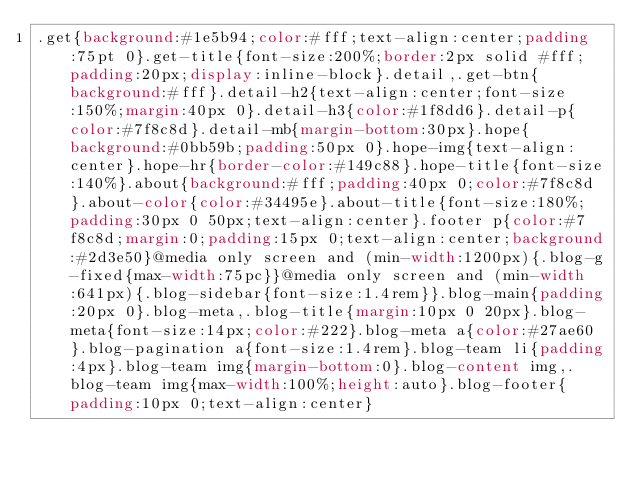<code> <loc_0><loc_0><loc_500><loc_500><_CSS_>.get{background:#1e5b94;color:#fff;text-align:center;padding:75pt 0}.get-title{font-size:200%;border:2px solid #fff;padding:20px;display:inline-block}.detail,.get-btn{background:#fff}.detail-h2{text-align:center;font-size:150%;margin:40px 0}.detail-h3{color:#1f8dd6}.detail-p{color:#7f8c8d}.detail-mb{margin-bottom:30px}.hope{background:#0bb59b;padding:50px 0}.hope-img{text-align:center}.hope-hr{border-color:#149c88}.hope-title{font-size:140%}.about{background:#fff;padding:40px 0;color:#7f8c8d}.about-color{color:#34495e}.about-title{font-size:180%;padding:30px 0 50px;text-align:center}.footer p{color:#7f8c8d;margin:0;padding:15px 0;text-align:center;background:#2d3e50}@media only screen and (min-width:1200px){.blog-g-fixed{max-width:75pc}}@media only screen and (min-width:641px){.blog-sidebar{font-size:1.4rem}}.blog-main{padding:20px 0}.blog-meta,.blog-title{margin:10px 0 20px}.blog-meta{font-size:14px;color:#222}.blog-meta a{color:#27ae60}.blog-pagination a{font-size:1.4rem}.blog-team li{padding:4px}.blog-team img{margin-bottom:0}.blog-content img,.blog-team img{max-width:100%;height:auto}.blog-footer{padding:10px 0;text-align:center}</code> 